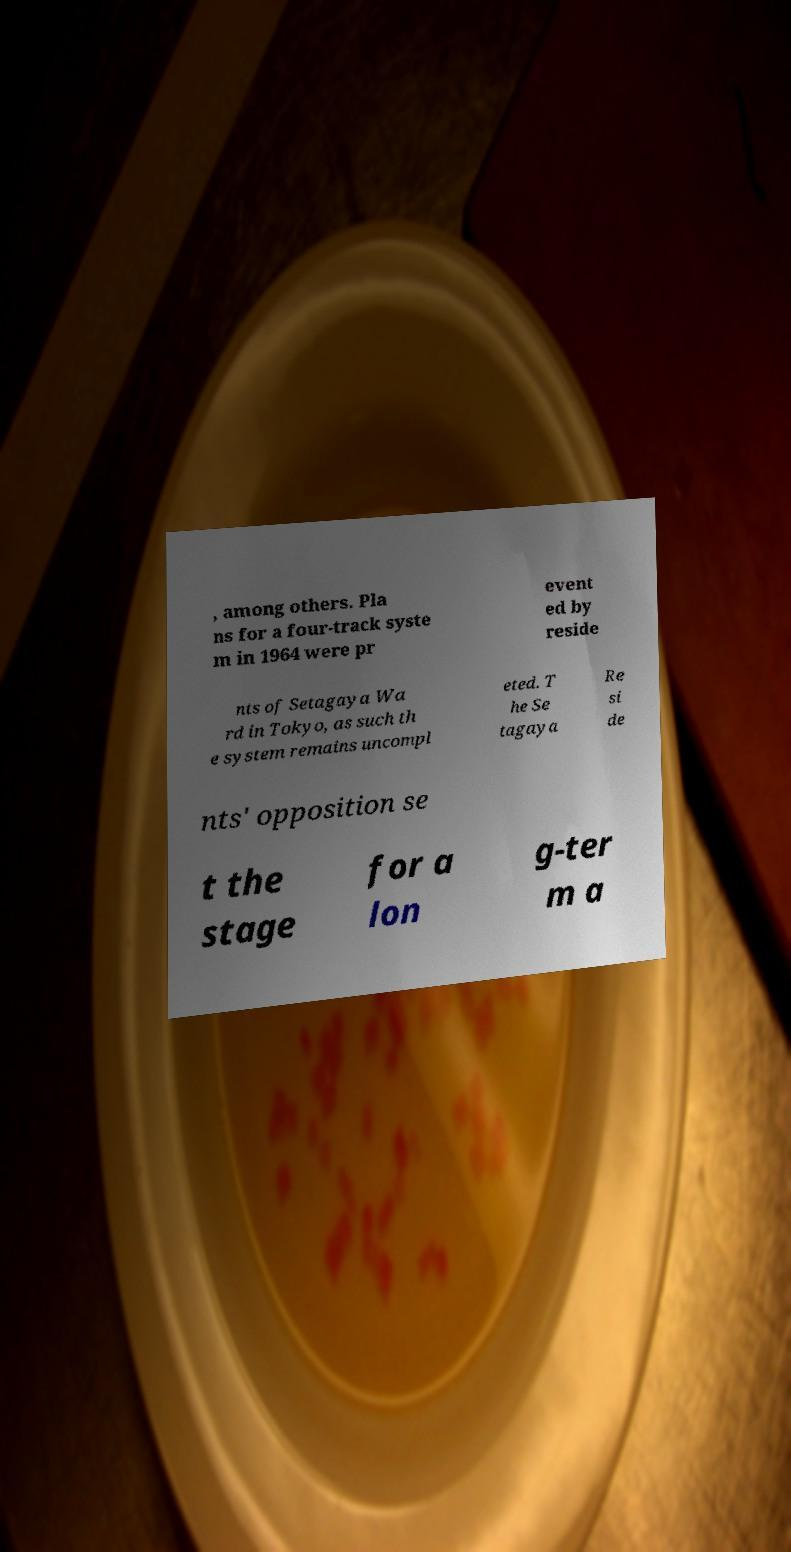I need the written content from this picture converted into text. Can you do that? , among others. Pla ns for a four-track syste m in 1964 were pr event ed by reside nts of Setagaya Wa rd in Tokyo, as such th e system remains uncompl eted. T he Se tagaya Re si de nts' opposition se t the stage for a lon g-ter m a 